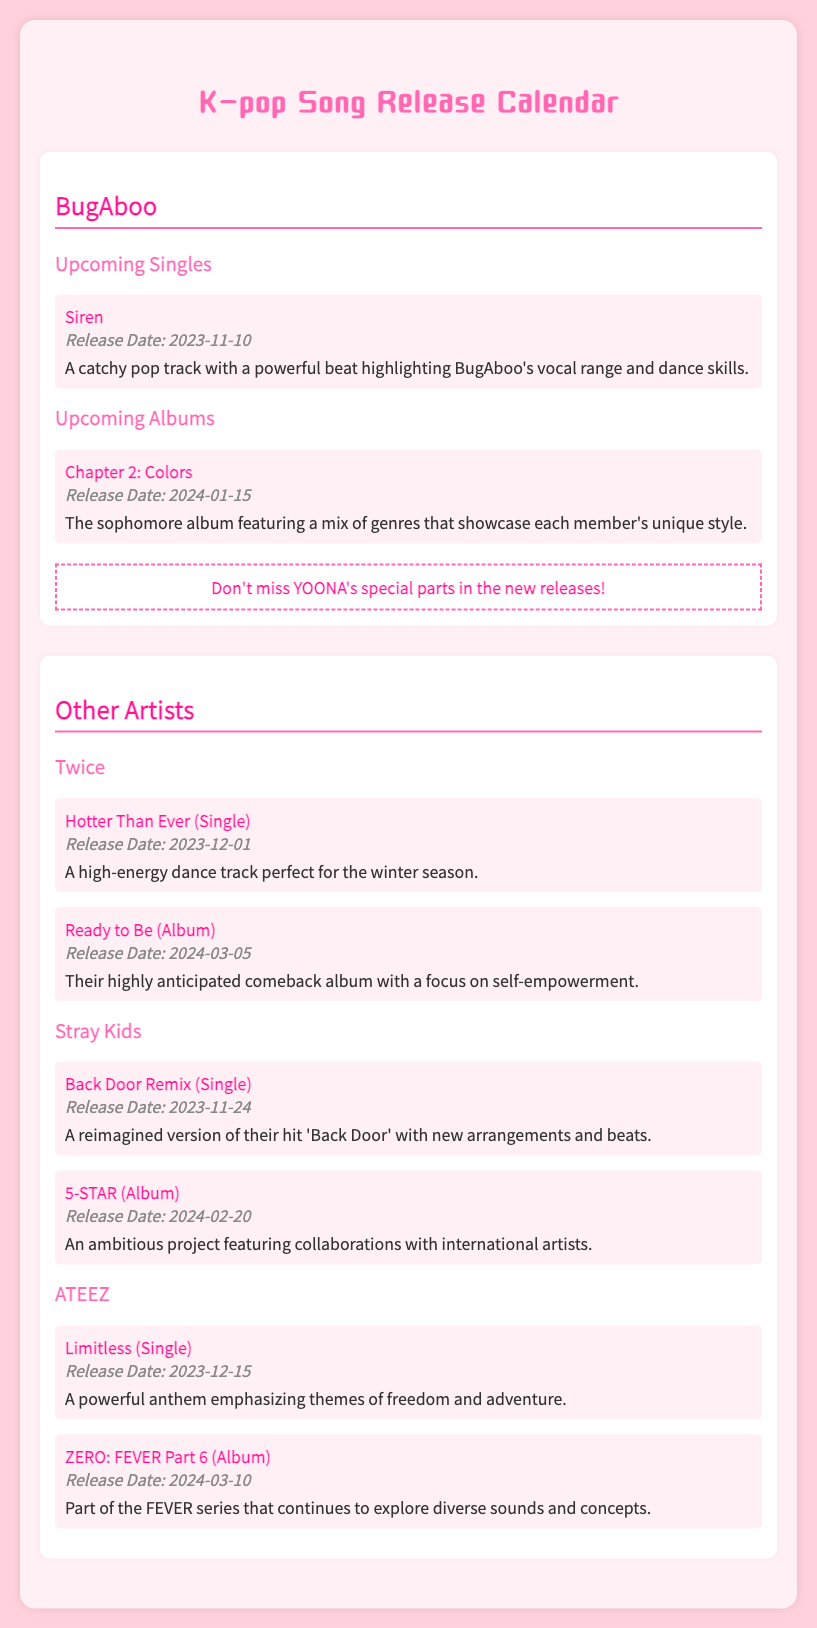What is the title of BugAboo's upcoming single? The title of BugAboo's upcoming single is "Siren."
Answer: Siren When is the release date for BugAboo's album? BugAboo's album "Chapter 2: Colors" is set to be released on 2024-01-15.
Answer: 2024-01-15 Which artist has a single titled "Back Door Remix"? The artist with a single titled "Back Door Remix" is Stray Kids.
Answer: Stray Kids What special event is highlighted for BugAboo's new releases? The document states that there's a special emphasis on YOONA's parts in the new releases.
Answer: YOONA's special parts What is the release date for the "Hotter Than Ever" single by Twice? The "Hotter Than Ever" single by Twice is scheduled for release on 2023-12-01.
Answer: 2023-12-01 How many singles are listed for ATEEZ? ATEEZ has one single listed in the document.
Answer: one What is the theme emphasized in ATEEZ's "Limitless"? The theme emphasized in ATEEZ's "Limitless" is freedom and adventure.
Answer: freedom and adventure Which group's album's release is the latest listed in the document? The latest album release listed in the document is by Stray Kids with "5-STAR."
Answer: Stray Kids What genre is BugAboo's upcoming song "Siren"? The genre of BugAboo's upcoming song "Siren" is catchy pop.
Answer: catchy pop 